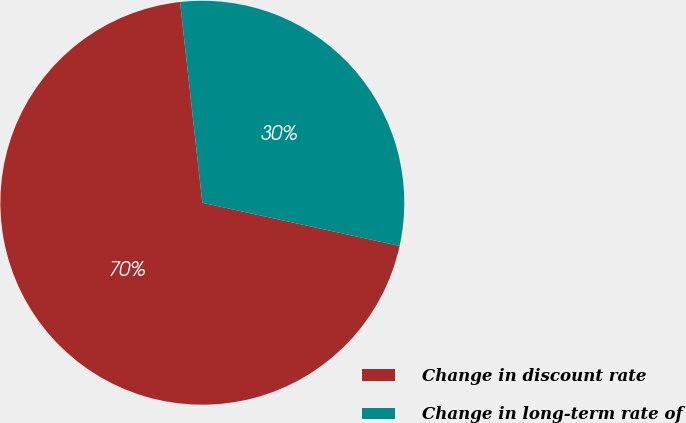<chart> <loc_0><loc_0><loc_500><loc_500><pie_chart><fcel>Change in discount rate<fcel>Change in long-term rate of<nl><fcel>69.81%<fcel>30.19%<nl></chart> 